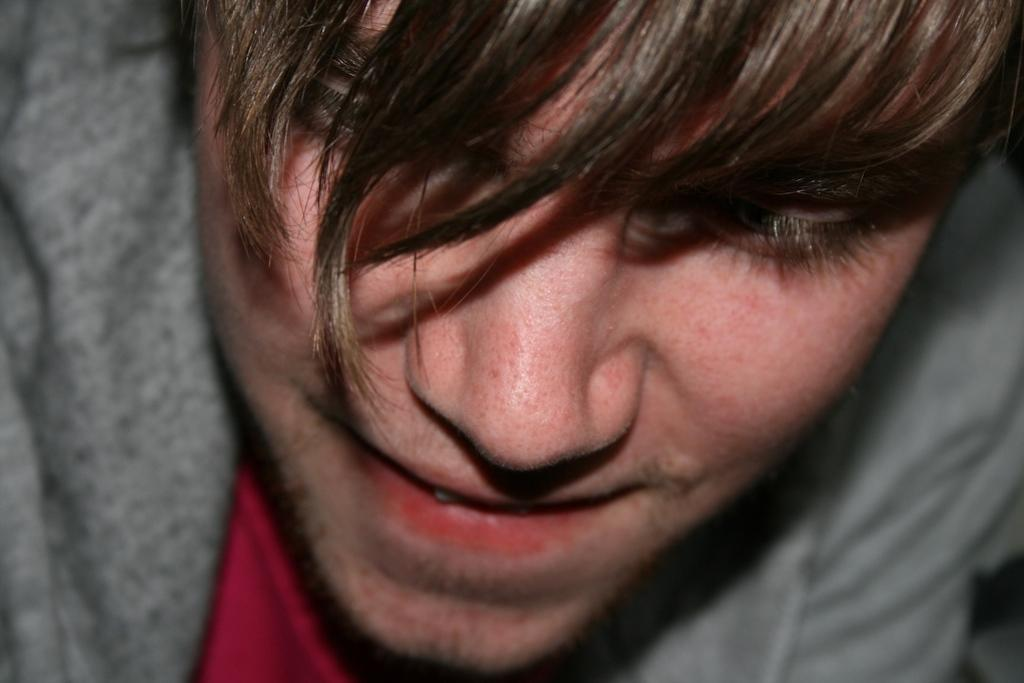What is the main subject of the image? There is a man in the image. What is the man wearing in the image? The man is wearing a brown color jacket. What type of root can be seen growing near the man in the image? There is no root visible in the image; it only features a man wearing a brown color jacket. Is the man in the image at a hospital? The image does not provide any information about the man's location or the presence of a hospital. 